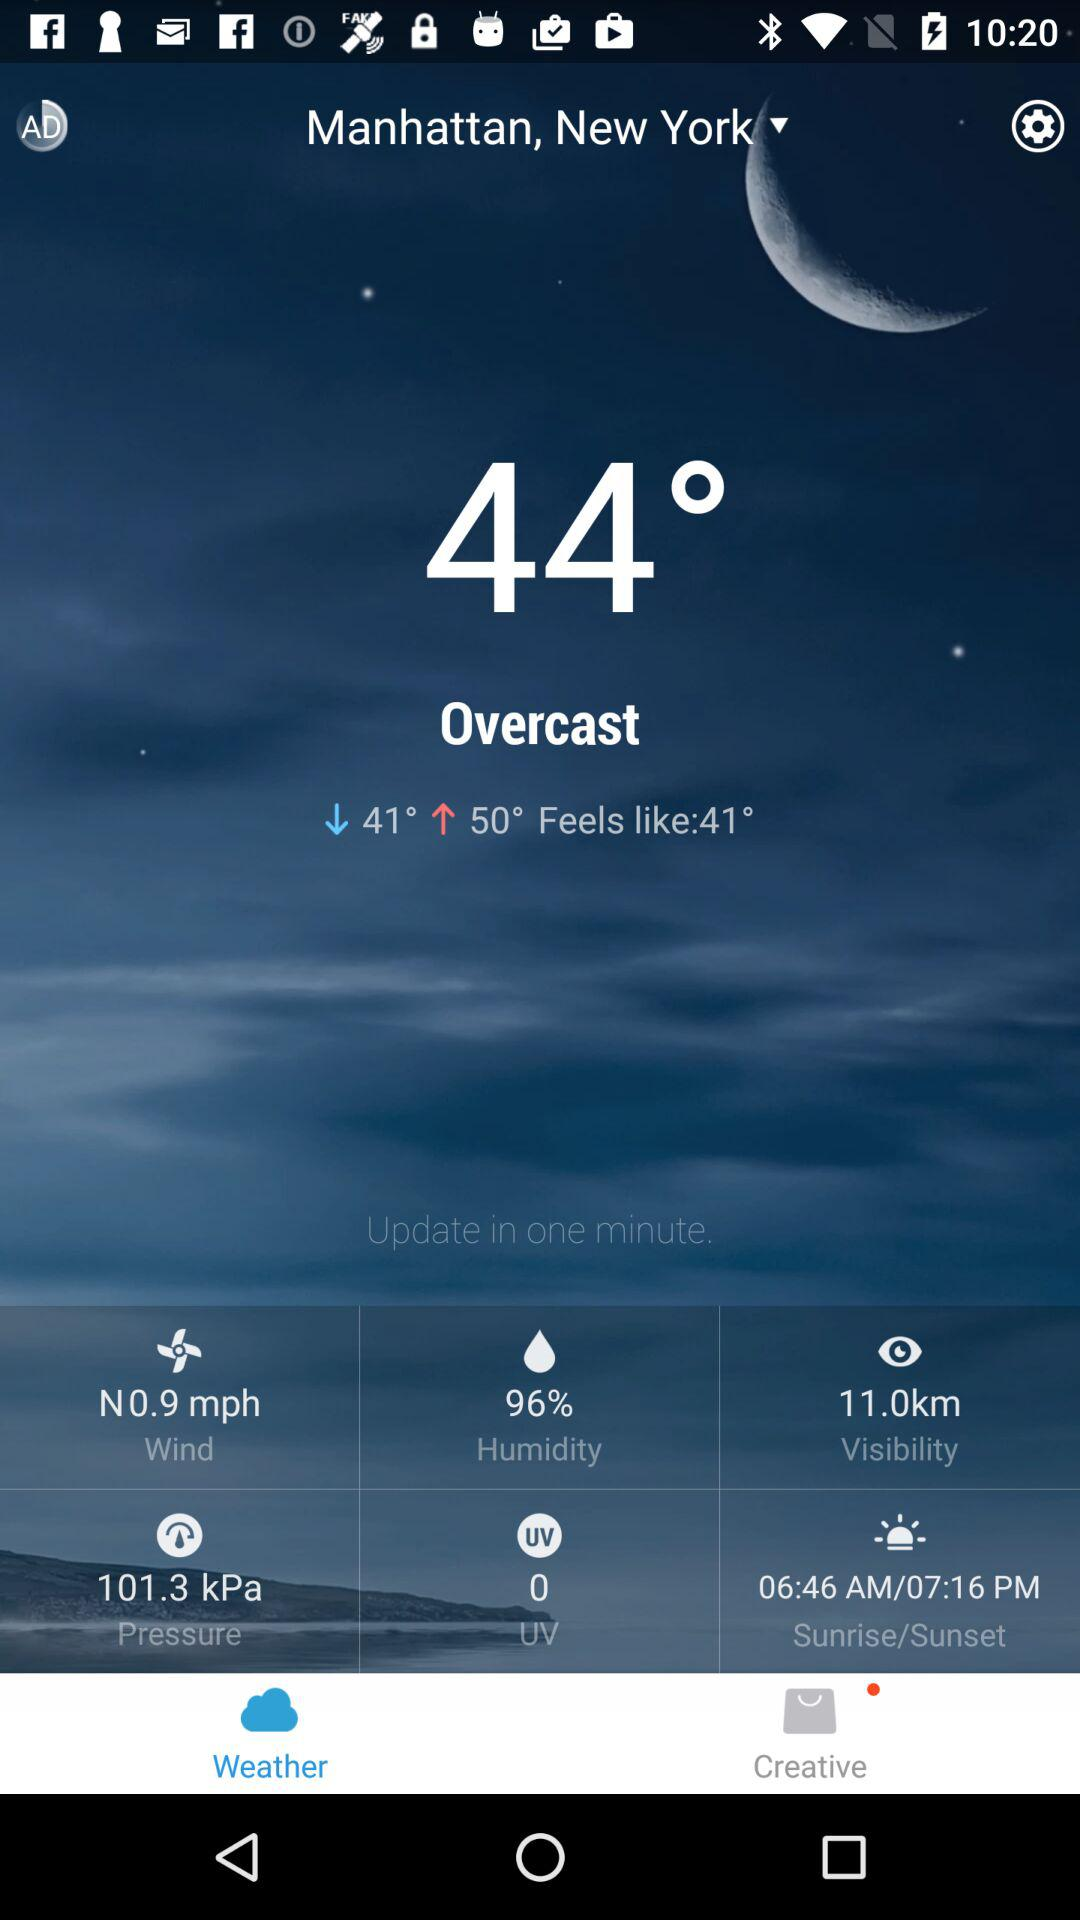What is the humidity percentage?
Answer the question using a single word or phrase. 96% 